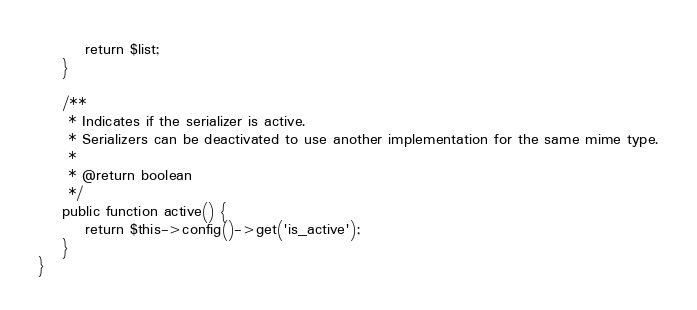Convert code to text. <code><loc_0><loc_0><loc_500><loc_500><_PHP_>        return $list;
    }

    /**
     * Indicates if the serializer is active.
     * Serializers can be deactivated to use another implementation for the same mime type.
     *
     * @return boolean
     */
    public function active() {
        return $this->config()->get('is_active');
    }
}
</code> 